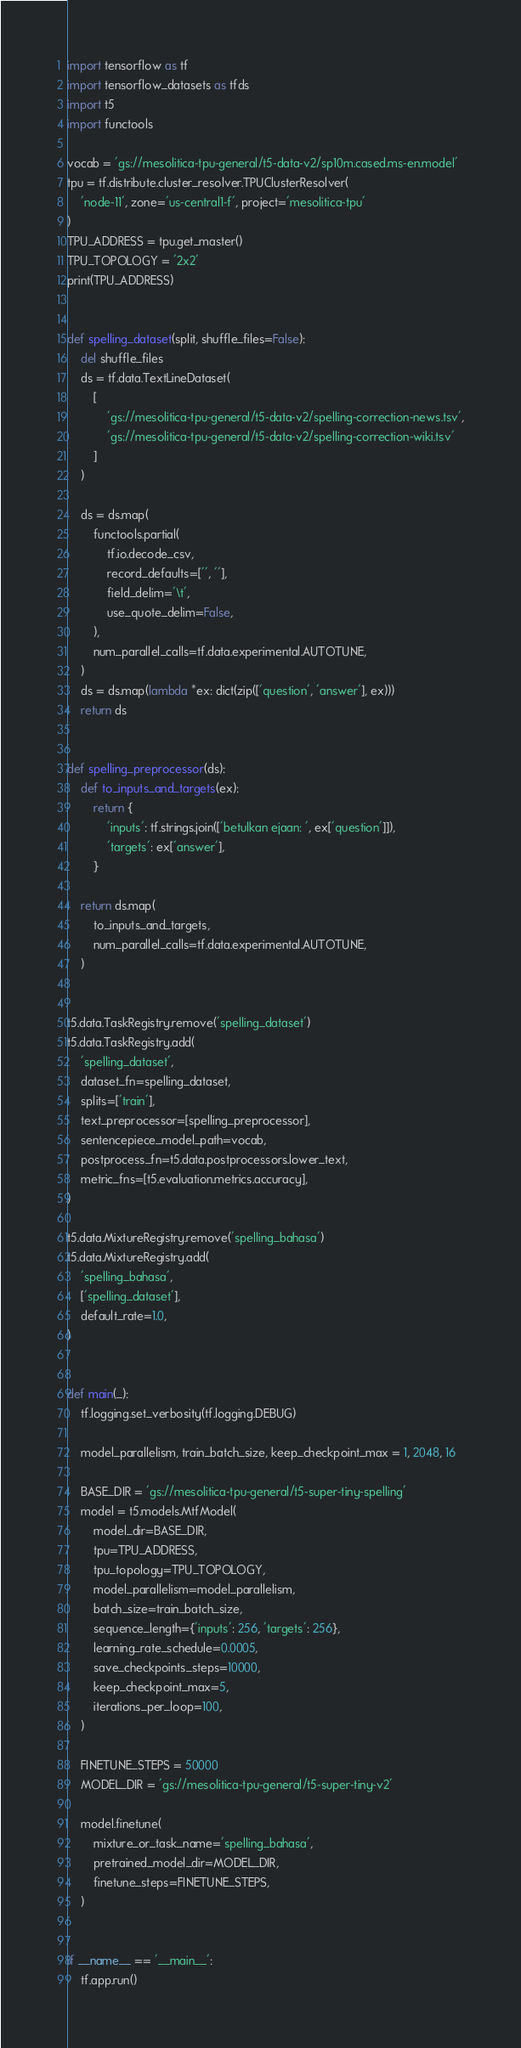<code> <loc_0><loc_0><loc_500><loc_500><_Python_>import tensorflow as tf
import tensorflow_datasets as tfds
import t5
import functools

vocab = 'gs://mesolitica-tpu-general/t5-data-v2/sp10m.cased.ms-en.model'
tpu = tf.distribute.cluster_resolver.TPUClusterResolver(
    'node-11', zone='us-central1-f', project='mesolitica-tpu'
)
TPU_ADDRESS = tpu.get_master()
TPU_TOPOLOGY = '2x2'
print(TPU_ADDRESS)


def spelling_dataset(split, shuffle_files=False):
    del shuffle_files
    ds = tf.data.TextLineDataset(
        [
            'gs://mesolitica-tpu-general/t5-data-v2/spelling-correction-news.tsv',
            'gs://mesolitica-tpu-general/t5-data-v2/spelling-correction-wiki.tsv'
        ]
    )

    ds = ds.map(
        functools.partial(
            tf.io.decode_csv,
            record_defaults=['', ''],
            field_delim='\t',
            use_quote_delim=False,
        ),
        num_parallel_calls=tf.data.experimental.AUTOTUNE,
    )
    ds = ds.map(lambda *ex: dict(zip(['question', 'answer'], ex)))
    return ds


def spelling_preprocessor(ds):
    def to_inputs_and_targets(ex):
        return {
            'inputs': tf.strings.join(['betulkan ejaan: ', ex['question']]),
            'targets': ex['answer'],
        }

    return ds.map(
        to_inputs_and_targets,
        num_parallel_calls=tf.data.experimental.AUTOTUNE,
    )


t5.data.TaskRegistry.remove('spelling_dataset')
t5.data.TaskRegistry.add(
    'spelling_dataset',
    dataset_fn=spelling_dataset,
    splits=['train'],
    text_preprocessor=[spelling_preprocessor],
    sentencepiece_model_path=vocab,
    postprocess_fn=t5.data.postprocessors.lower_text,
    metric_fns=[t5.evaluation.metrics.accuracy],
)

t5.data.MixtureRegistry.remove('spelling_bahasa')
t5.data.MixtureRegistry.add(
    'spelling_bahasa',
    ['spelling_dataset'],
    default_rate=1.0,
)


def main(_):
    tf.logging.set_verbosity(tf.logging.DEBUG)

    model_parallelism, train_batch_size, keep_checkpoint_max = 1, 2048, 16

    BASE_DIR = 'gs://mesolitica-tpu-general/t5-super-tiny-spelling'
    model = t5.models.MtfModel(
        model_dir=BASE_DIR,
        tpu=TPU_ADDRESS,
        tpu_topology=TPU_TOPOLOGY,
        model_parallelism=model_parallelism,
        batch_size=train_batch_size,
        sequence_length={'inputs': 256, 'targets': 256},
        learning_rate_schedule=0.0005,
        save_checkpoints_steps=10000,
        keep_checkpoint_max=5,
        iterations_per_loop=100,
    )

    FINETUNE_STEPS = 50000
    MODEL_DIR = 'gs://mesolitica-tpu-general/t5-super-tiny-v2'

    model.finetune(
        mixture_or_task_name='spelling_bahasa',
        pretrained_model_dir=MODEL_DIR,
        finetune_steps=FINETUNE_STEPS,
    )


if __name__ == '__main__':
    tf.app.run()
</code> 